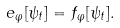<formula> <loc_0><loc_0><loc_500><loc_500>e _ { \varphi } [ \psi _ { t } ] = f _ { \varphi } [ \psi _ { t } ] .</formula> 